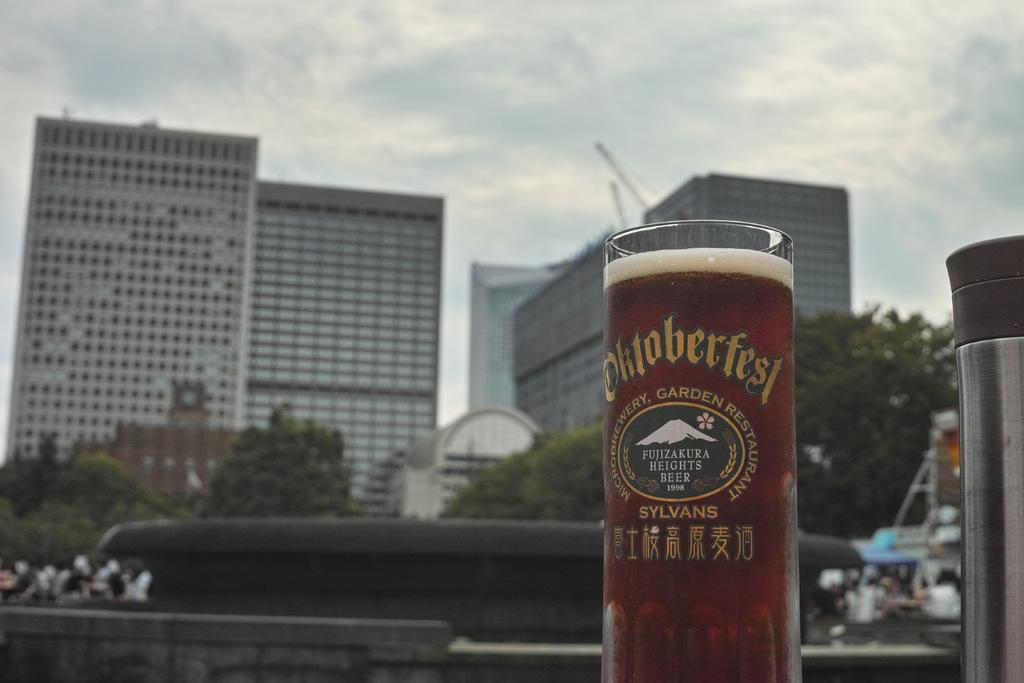<image>
Relay a brief, clear account of the picture shown. A full Oktoberfest glass is shown against a cloudy sky. 